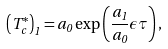Convert formula to latex. <formula><loc_0><loc_0><loc_500><loc_500>\left ( T _ { c } ^ { * } \right ) _ { 1 } = a _ { 0 } \exp \left ( \frac { a _ { 1 } } { a _ { 0 } } \epsilon \tau \right ) ,</formula> 